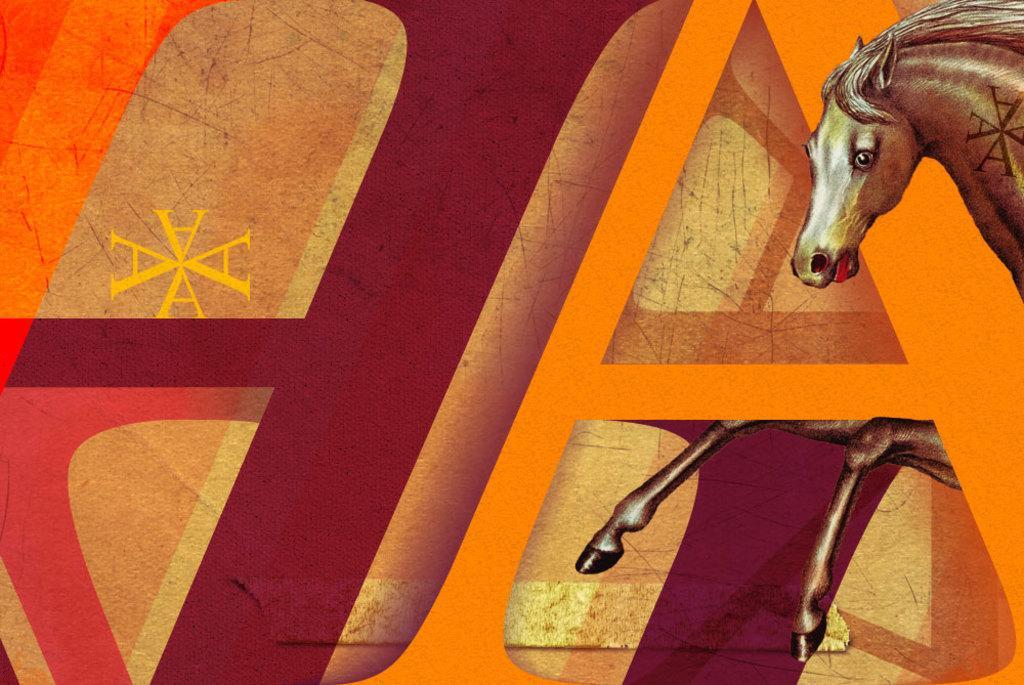In one or two sentences, can you explain what this image depicts? This picture is painting. On the right side of the image we can see a horse. On the left side of the image we can see some text. In the background of the image there are different colors. 